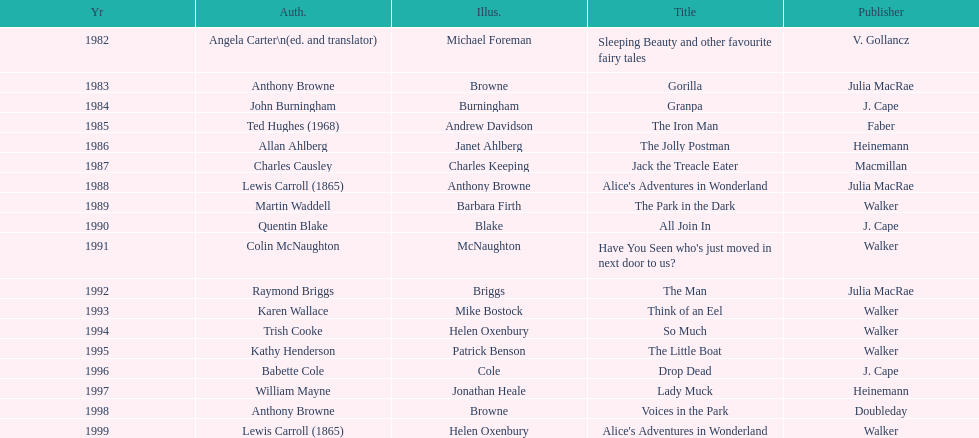What are the number of kurt maschler awards helen oxenbury has won? 2. 